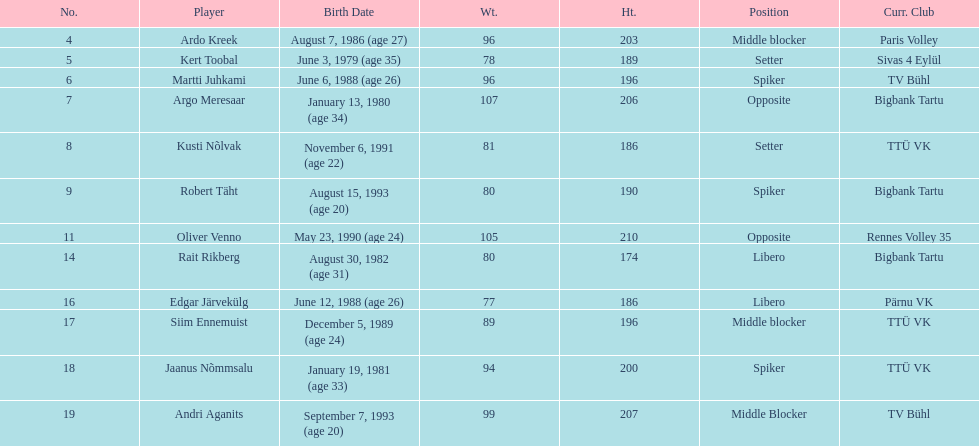Which player is taller than andri agantis? Oliver Venno. 